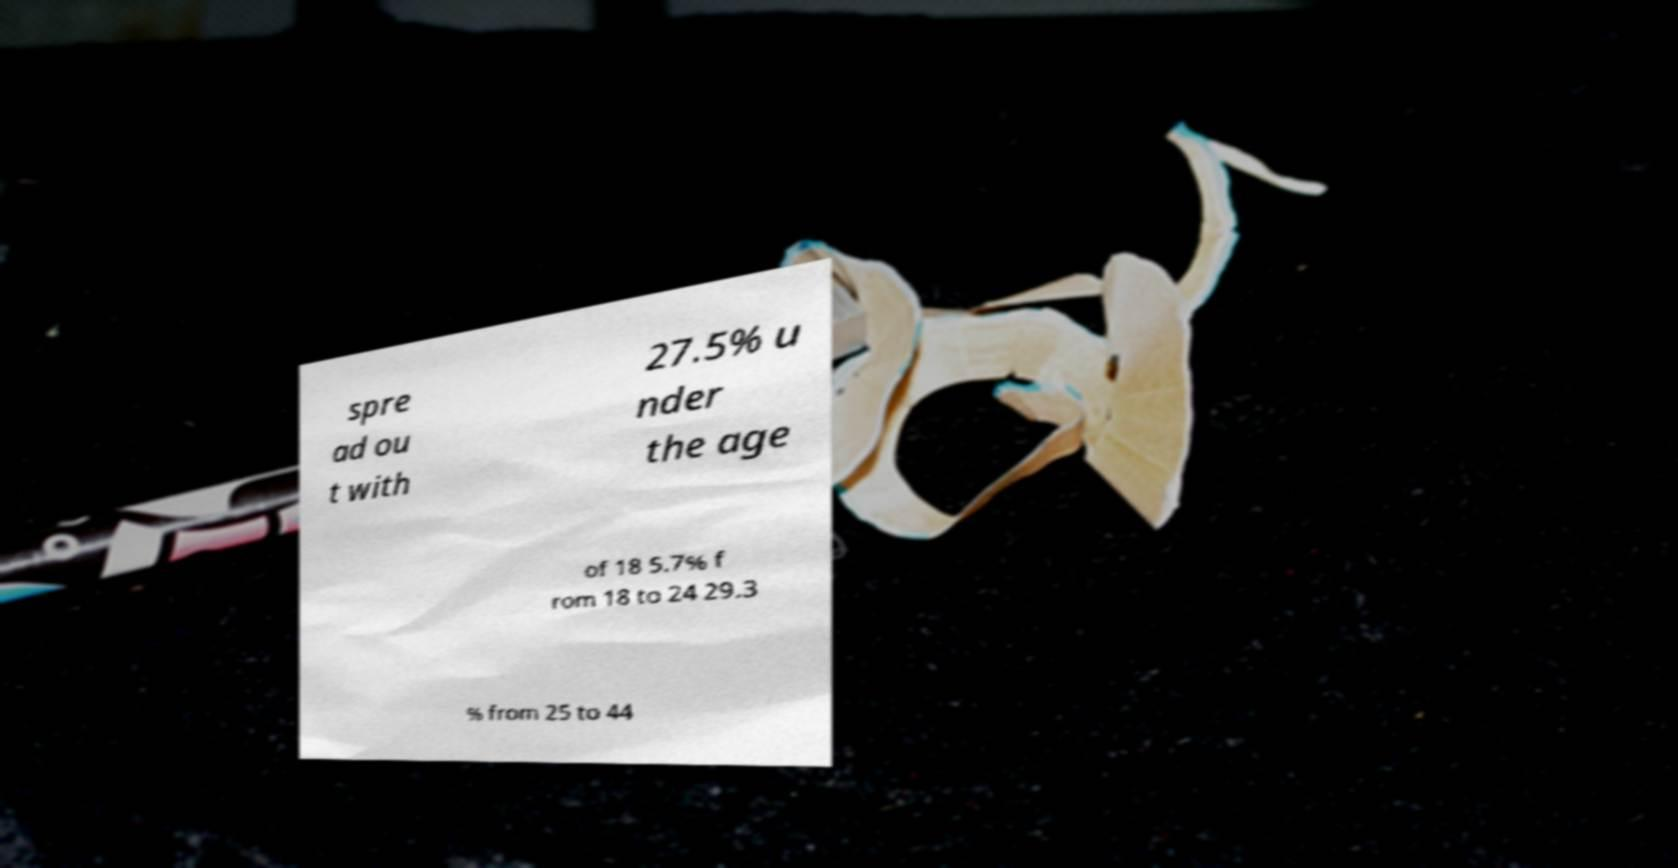What messages or text are displayed in this image? I need them in a readable, typed format. spre ad ou t with 27.5% u nder the age of 18 5.7% f rom 18 to 24 29.3 % from 25 to 44 